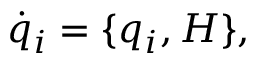<formula> <loc_0><loc_0><loc_500><loc_500>{ \dot { q } } _ { i } = \{ q _ { i } , H \} ,</formula> 